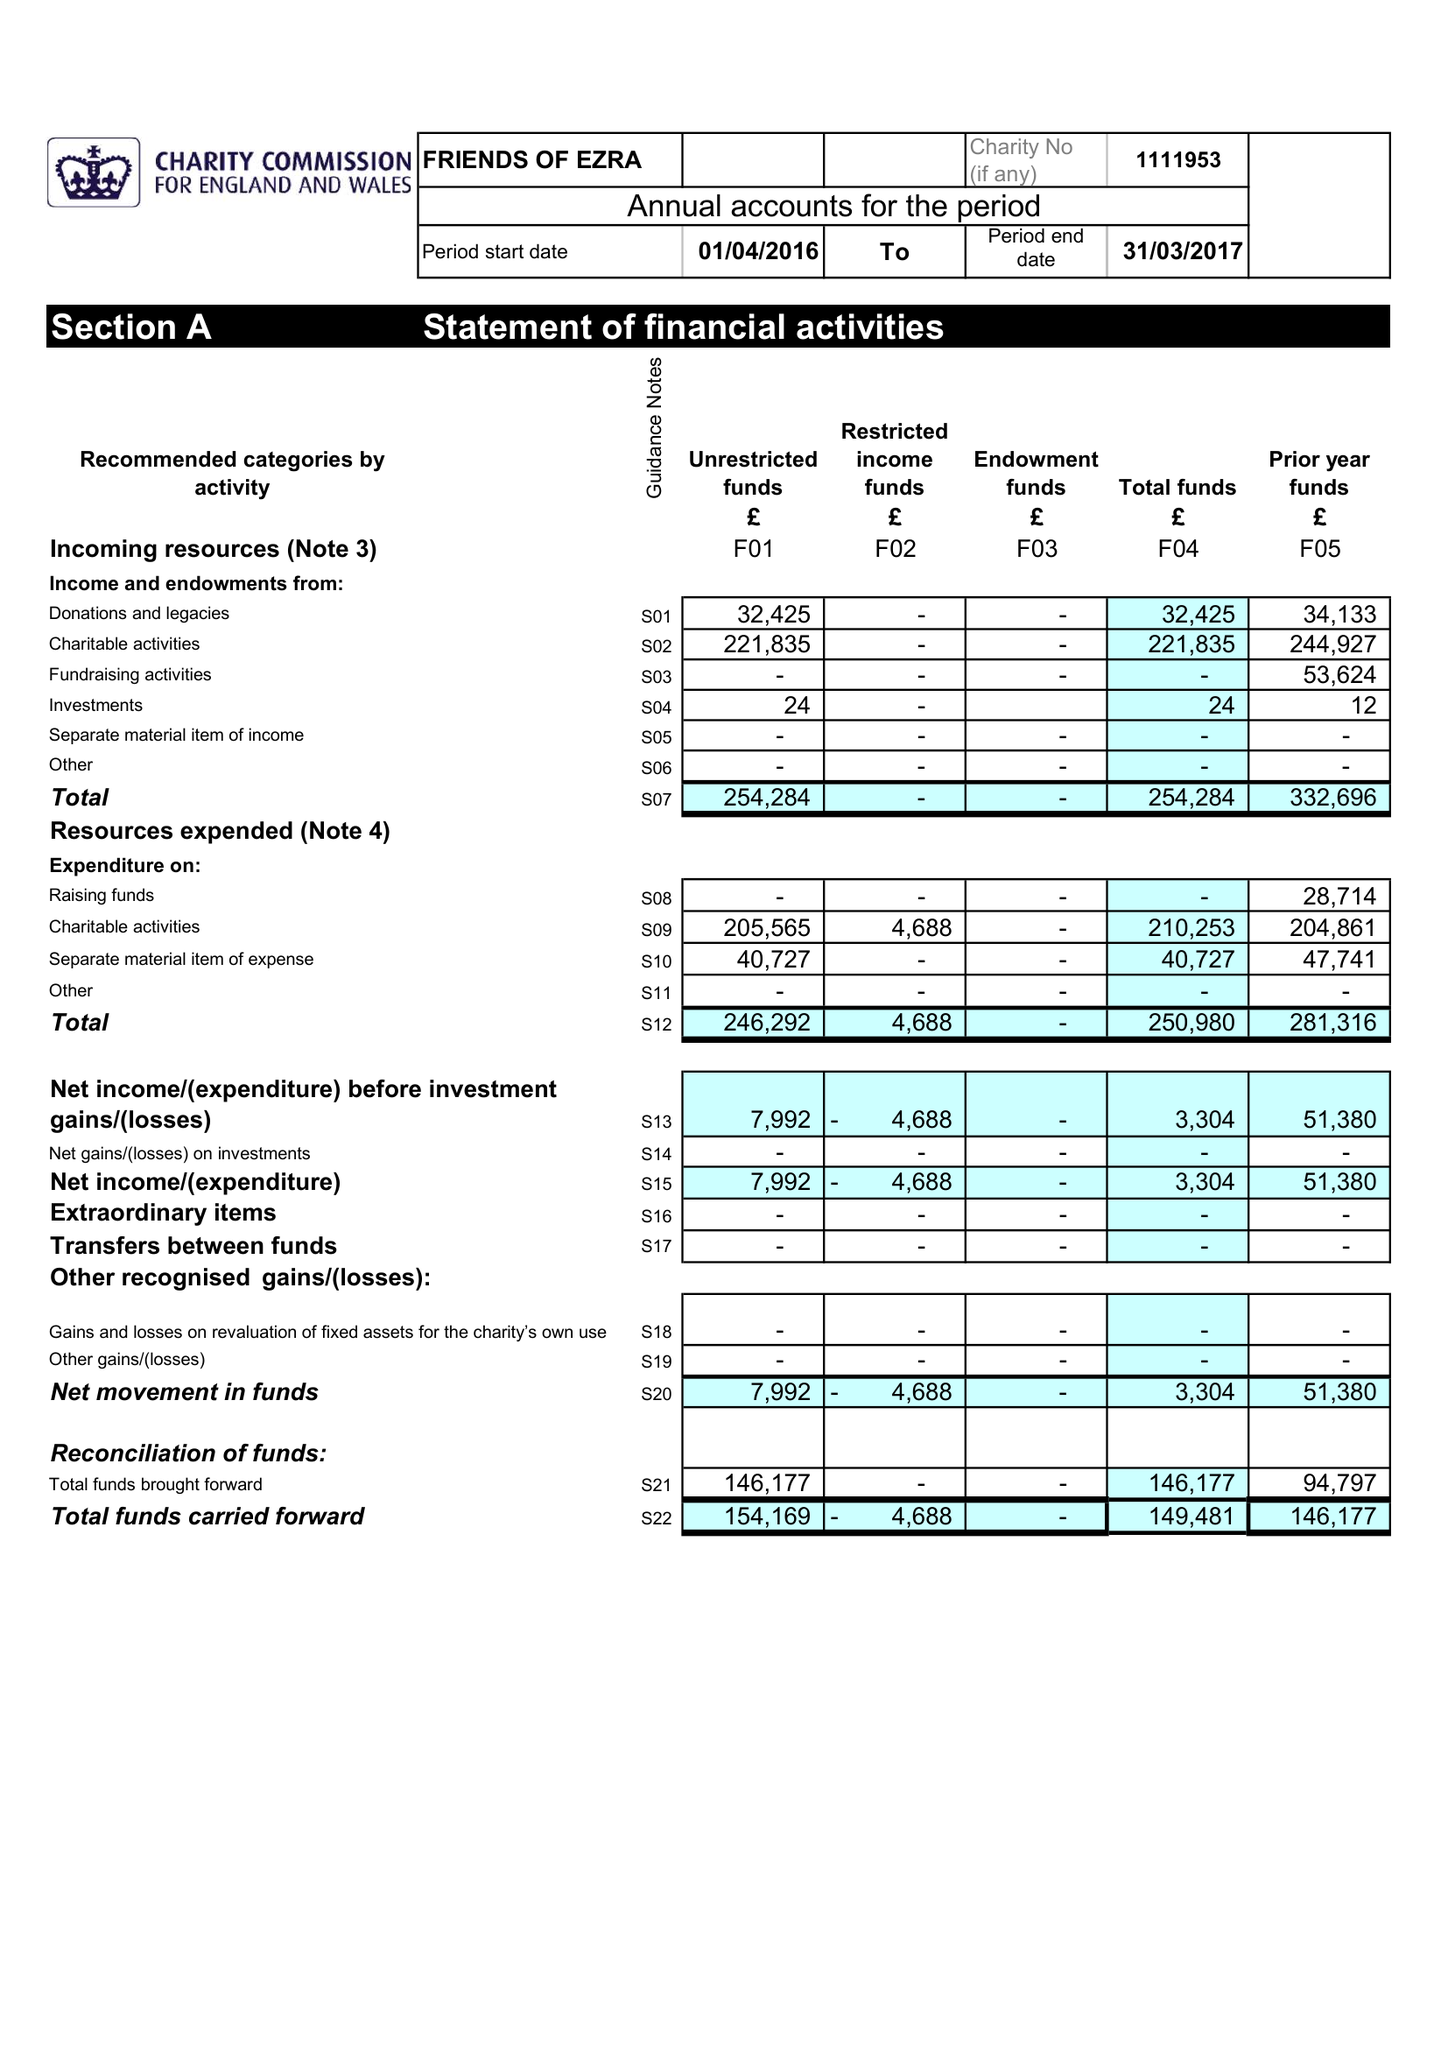What is the value for the charity_name?
Answer the question using a single word or phrase. Friends Of Ezra 